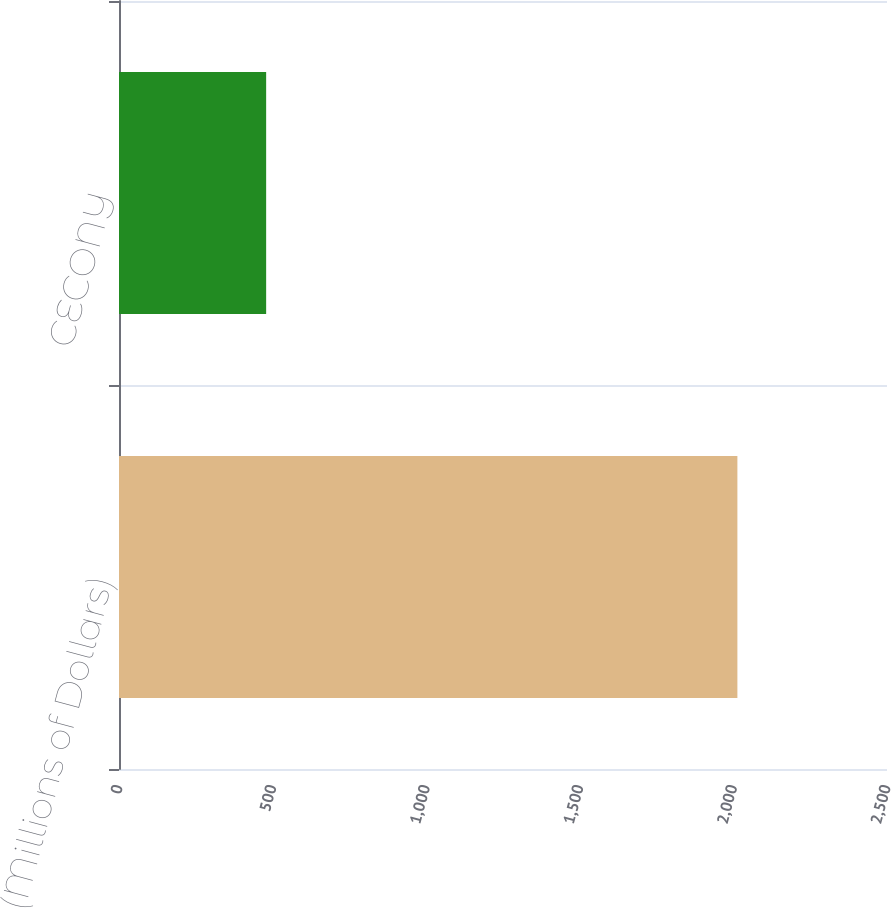<chart> <loc_0><loc_0><loc_500><loc_500><bar_chart><fcel>(Millions of Dollars)<fcel>CECONY<nl><fcel>2013<fcel>479<nl></chart> 